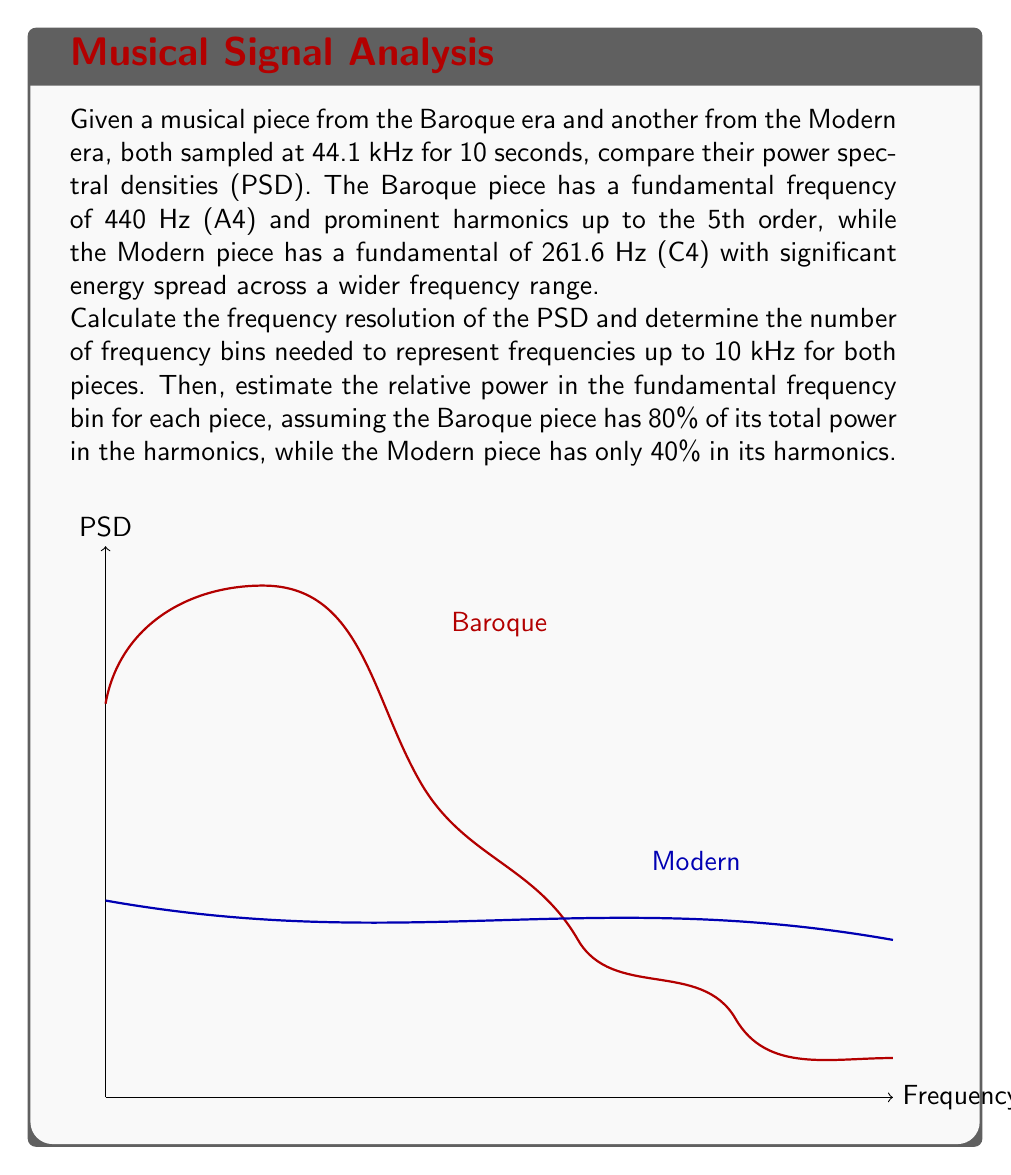Provide a solution to this math problem. Let's break this down step by step:

1) Frequency resolution calculation:
   The frequency resolution (Δf) is given by:
   $$\Delta f = \frac{f_s}{N}$$
   where $f_s$ is the sampling frequency and $N$ is the number of samples.
   
   $f_s = 44.1$ kHz, Duration = 10 s
   $N = 44100 \times 10 = 441000$ samples
   
   $$\Delta f = \frac{44100}{441000} = 0.1 \text{ Hz}$$

2) Number of frequency bins up to 10 kHz:
   $$\text{Number of bins} = \frac{10000 \text{ Hz}}{0.1 \text{ Hz/bin}} = 100000 \text{ bins}$$

3) Relative power in the fundamental frequency bin:

   For the Baroque piece:
   - Fundamental frequency: 440 Hz
   - 80% of power in harmonics, so 20% in fundamental
   - Fundamental bin: $\frac{440 \text{ Hz}}{0.1 \text{ Hz/bin}} = 4400^{th}$ bin
   
   For the Modern piece:
   - Fundamental frequency: 261.6 Hz
   - 40% of power in harmonics, so 60% in fundamental
   - Fundamental bin: $\frac{261.6 \text{ Hz}}{0.1 \text{ Hz/bin}} = 2616^{th}$ bin

   Assuming total power is 1 for both pieces:
   
   Baroque: Power in fundamental = $0.2$
   Modern: Power in fundamental = $0.6$

   Relative power = $\frac{\text{Modern}}{\text{Baroque}} = \frac{0.6}{0.2} = 3$

Therefore, the fundamental frequency bin of the Modern piece has 3 times more power than that of the Baroque piece.
Answer: Frequency resolution: 0.1 Hz; Bins up to 10 kHz: 100000; Relative power in fundamental: Modern/Baroque = 3 